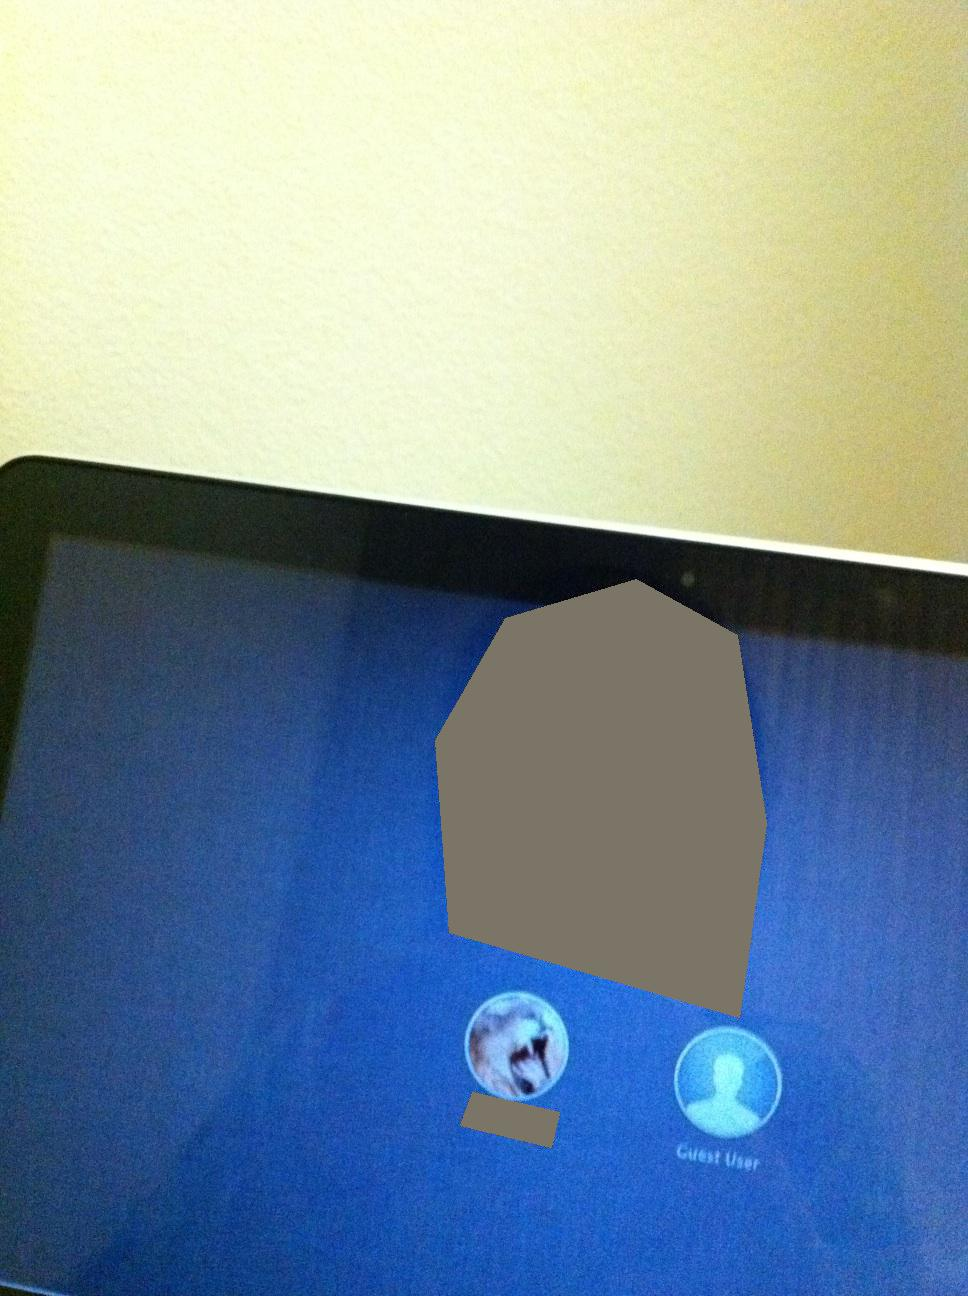Currently on the screen, which option is selected? Thank you. The image shows a login screen with two user options: a regular user (shown with an avatar) and a 'Guest User'. However, it is not clear which option is currently selected from the image. 